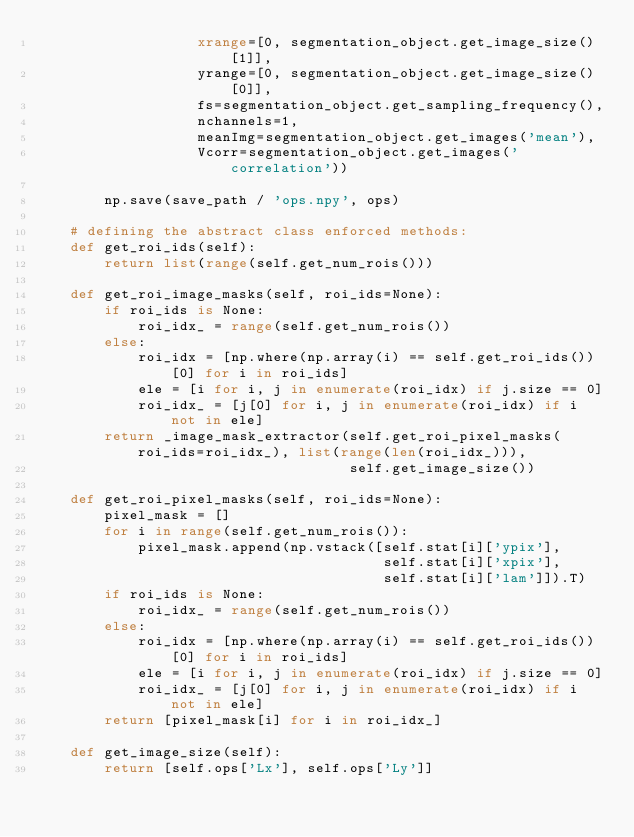<code> <loc_0><loc_0><loc_500><loc_500><_Python_>                   xrange=[0, segmentation_object.get_image_size()[1]],
                   yrange=[0, segmentation_object.get_image_size()[0]],
                   fs=segmentation_object.get_sampling_frequency(),
                   nchannels=1,
                   meanImg=segmentation_object.get_images('mean'),
                   Vcorr=segmentation_object.get_images('correlation'))

        np.save(save_path / 'ops.npy', ops)

    # defining the abstract class enforced methods:
    def get_roi_ids(self):
        return list(range(self.get_num_rois()))

    def get_roi_image_masks(self, roi_ids=None):
        if roi_ids is None:
            roi_idx_ = range(self.get_num_rois())
        else:
            roi_idx = [np.where(np.array(i) == self.get_roi_ids())[0] for i in roi_ids]
            ele = [i for i, j in enumerate(roi_idx) if j.size == 0]
            roi_idx_ = [j[0] for i, j in enumerate(roi_idx) if i not in ele]
        return _image_mask_extractor(self.get_roi_pixel_masks(roi_ids=roi_idx_), list(range(len(roi_idx_))),
                                     self.get_image_size())

    def get_roi_pixel_masks(self, roi_ids=None):
        pixel_mask = []
        for i in range(self.get_num_rois()):
            pixel_mask.append(np.vstack([self.stat[i]['ypix'],
                                         self.stat[i]['xpix'],
                                         self.stat[i]['lam']]).T)
        if roi_ids is None:
            roi_idx_ = range(self.get_num_rois())
        else:
            roi_idx = [np.where(np.array(i) == self.get_roi_ids())[0] for i in roi_ids]
            ele = [i for i, j in enumerate(roi_idx) if j.size == 0]
            roi_idx_ = [j[0] for i, j in enumerate(roi_idx) if i not in ele]
        return [pixel_mask[i] for i in roi_idx_]

    def get_image_size(self):
        return [self.ops['Lx'], self.ops['Ly']]
</code> 